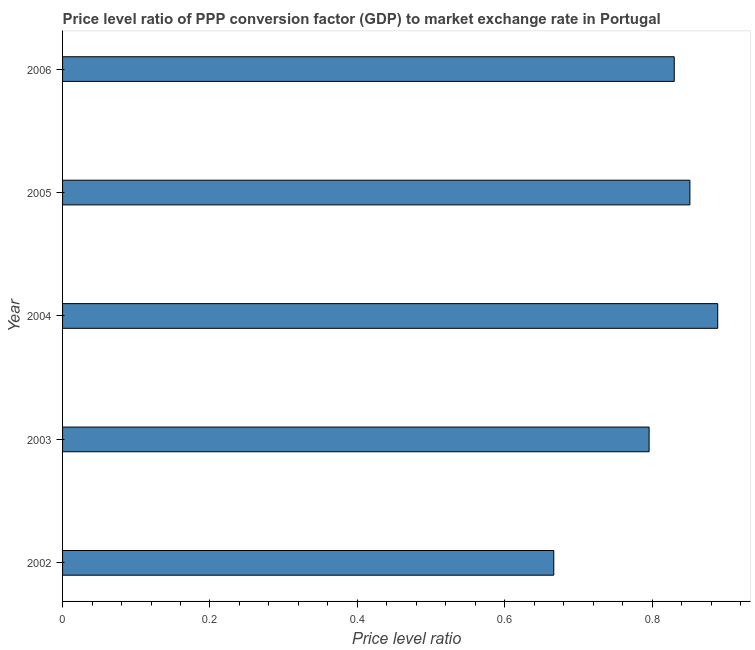What is the title of the graph?
Provide a short and direct response. Price level ratio of PPP conversion factor (GDP) to market exchange rate in Portugal. What is the label or title of the X-axis?
Offer a terse response. Price level ratio. What is the label or title of the Y-axis?
Keep it short and to the point. Year. What is the price level ratio in 2005?
Your response must be concise. 0.85. Across all years, what is the maximum price level ratio?
Provide a short and direct response. 0.89. Across all years, what is the minimum price level ratio?
Offer a terse response. 0.67. In which year was the price level ratio minimum?
Ensure brevity in your answer.  2002. What is the sum of the price level ratio?
Keep it short and to the point. 4.03. What is the difference between the price level ratio in 2004 and 2005?
Your answer should be compact. 0.04. What is the average price level ratio per year?
Your response must be concise. 0.81. What is the median price level ratio?
Give a very brief answer. 0.83. In how many years, is the price level ratio greater than 0.48 ?
Your response must be concise. 5. What is the ratio of the price level ratio in 2002 to that in 2004?
Your answer should be compact. 0.75. Is the price level ratio in 2002 less than that in 2005?
Your response must be concise. Yes. What is the difference between the highest and the second highest price level ratio?
Ensure brevity in your answer.  0.04. Is the sum of the price level ratio in 2003 and 2006 greater than the maximum price level ratio across all years?
Provide a succinct answer. Yes. What is the difference between the highest and the lowest price level ratio?
Make the answer very short. 0.22. In how many years, is the price level ratio greater than the average price level ratio taken over all years?
Your answer should be compact. 3. How many bars are there?
Offer a terse response. 5. How many years are there in the graph?
Ensure brevity in your answer.  5. Are the values on the major ticks of X-axis written in scientific E-notation?
Offer a terse response. No. What is the Price level ratio of 2002?
Ensure brevity in your answer.  0.67. What is the Price level ratio of 2003?
Make the answer very short. 0.8. What is the Price level ratio in 2004?
Ensure brevity in your answer.  0.89. What is the Price level ratio in 2005?
Give a very brief answer. 0.85. What is the Price level ratio in 2006?
Provide a short and direct response. 0.83. What is the difference between the Price level ratio in 2002 and 2003?
Make the answer very short. -0.13. What is the difference between the Price level ratio in 2002 and 2004?
Your response must be concise. -0.22. What is the difference between the Price level ratio in 2002 and 2005?
Your answer should be very brief. -0.18. What is the difference between the Price level ratio in 2002 and 2006?
Give a very brief answer. -0.16. What is the difference between the Price level ratio in 2003 and 2004?
Provide a succinct answer. -0.09. What is the difference between the Price level ratio in 2003 and 2005?
Keep it short and to the point. -0.06. What is the difference between the Price level ratio in 2003 and 2006?
Keep it short and to the point. -0.03. What is the difference between the Price level ratio in 2004 and 2005?
Your response must be concise. 0.04. What is the difference between the Price level ratio in 2004 and 2006?
Provide a short and direct response. 0.06. What is the difference between the Price level ratio in 2005 and 2006?
Ensure brevity in your answer.  0.02. What is the ratio of the Price level ratio in 2002 to that in 2003?
Ensure brevity in your answer.  0.84. What is the ratio of the Price level ratio in 2002 to that in 2005?
Provide a succinct answer. 0.78. What is the ratio of the Price level ratio in 2002 to that in 2006?
Offer a terse response. 0.8. What is the ratio of the Price level ratio in 2003 to that in 2004?
Provide a short and direct response. 0.9. What is the ratio of the Price level ratio in 2003 to that in 2005?
Ensure brevity in your answer.  0.94. What is the ratio of the Price level ratio in 2004 to that in 2005?
Ensure brevity in your answer.  1.04. What is the ratio of the Price level ratio in 2004 to that in 2006?
Provide a short and direct response. 1.07. What is the ratio of the Price level ratio in 2005 to that in 2006?
Make the answer very short. 1.03. 